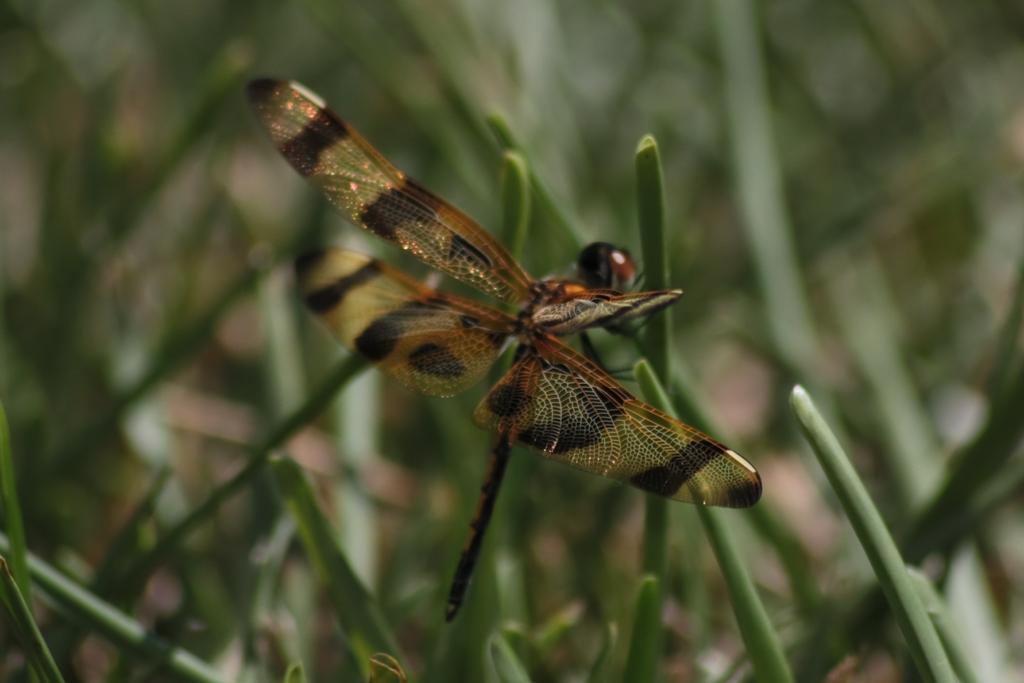Could you give a brief overview of what you see in this image? In this image, we can see a dragonfly on the blur background. 